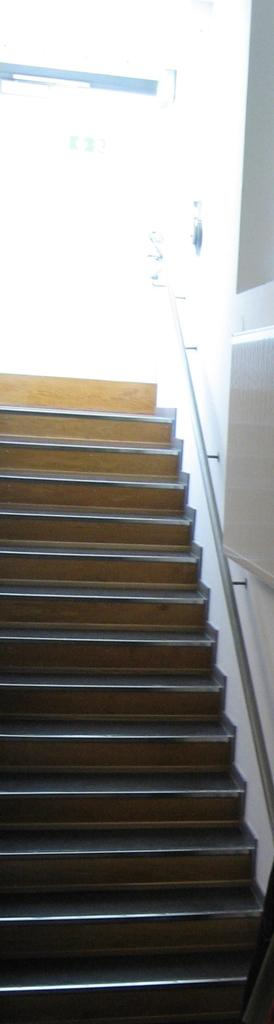What type of structure is present in the image? There is a staircase in the image. Can you see any rats running up and down the staircase in the image? There are no rats visible in the image; it only features a staircase. 